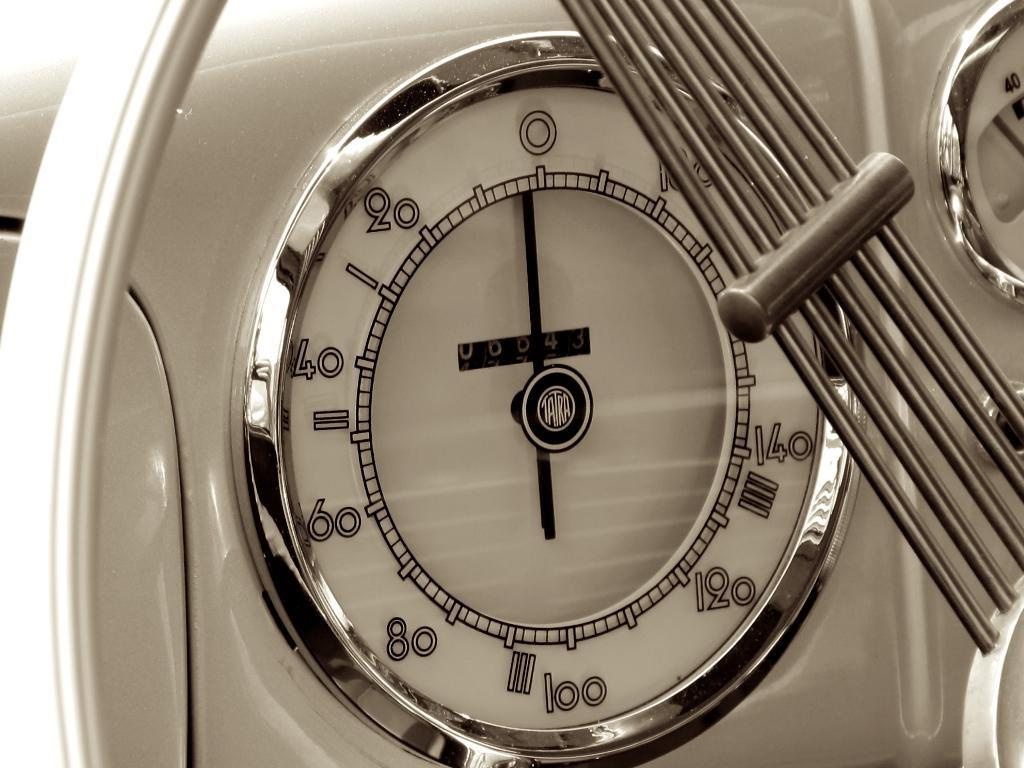<image>
Summarize the visual content of the image. A Tatra clock is white, chrome and black. 